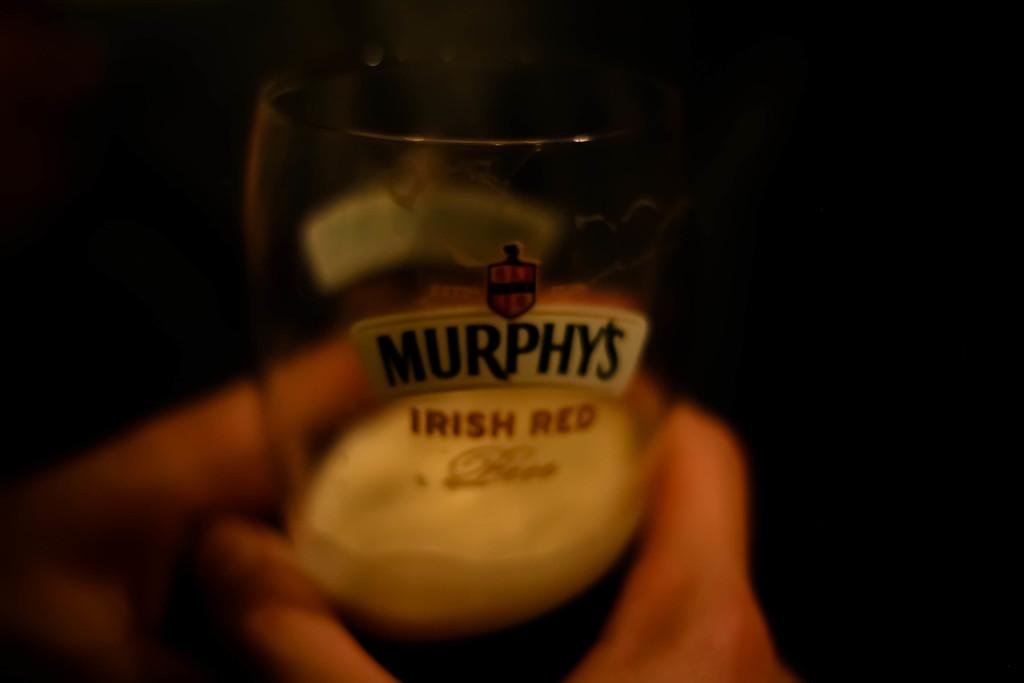What kind of beer is this?
Provide a short and direct response. Murphy's irish red. 